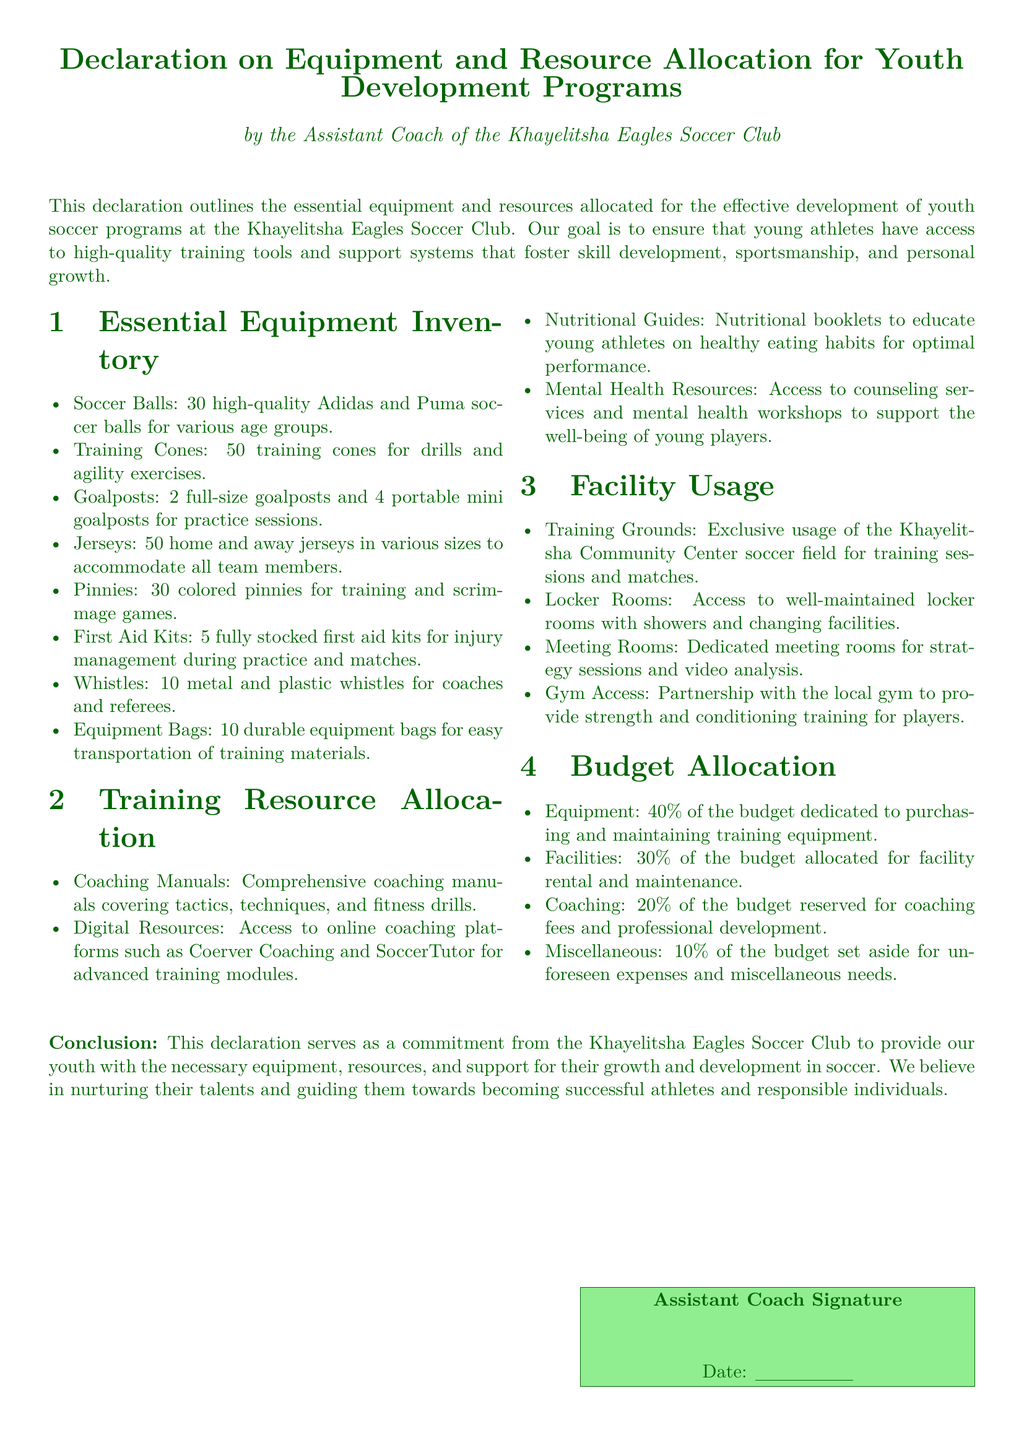What is the total number of soccer balls? The document specifies there are 30 high-quality soccer balls for various age groups.
Answer: 30 How many first aid kits are available? The declaration lists that there are 5 fully stocked first aid kits for injury management.
Answer: 5 What percentage of the budget is allocated to equipment? The document states that 40% of the budget is dedicated to purchasing and maintaining training equipment.
Answer: 40% What type of training resource is provided for mental health? The declaration mentions access to counseling services and mental health workshops to support players.
Answer: Counseling services How many training cones are included in the inventory? The document lists 50 training cones for drills and agility exercises.
Answer: 50 How many goalposts are included in the inventory? The declaration specifies that there are 2 full-size goalposts and 4 portable mini goalposts for practice sessions.
Answer: 6 What is the main purpose of the declaration? The purpose is to outline the essential equipment and resources allocated for the effective development of youth soccer programs.
Answer: Youth development programs Which facility provides strength and conditioning training for players? The document mentions a partnership with the local gym for strength and conditioning training.
Answer: Local gym How many jerseys are available for team members? The declaration indicates there are 50 home and away jerseys in various sizes.
Answer: 50 